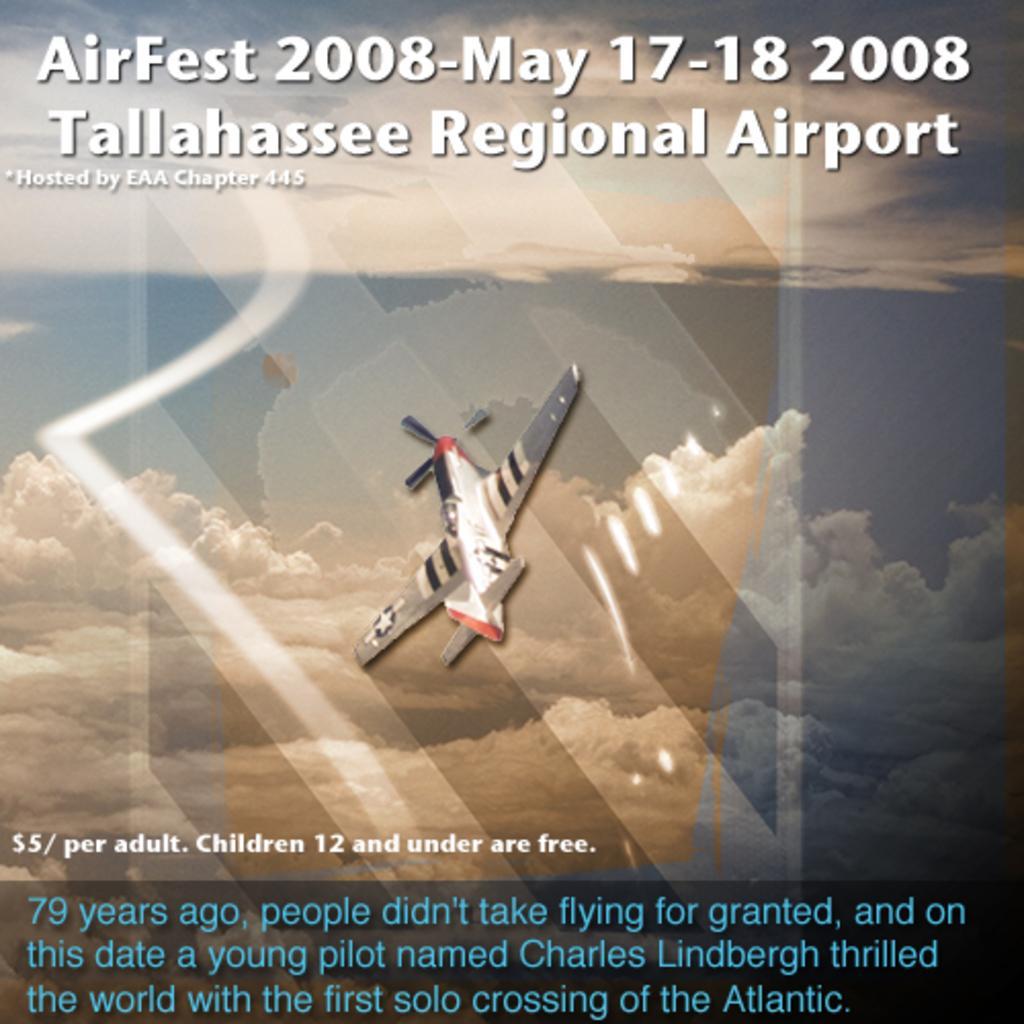Please provide a concise description of this image. In this image we can see aeroplane in the air. In the background we can see sky and clouds. At the top and bottom of the image we can see text. 